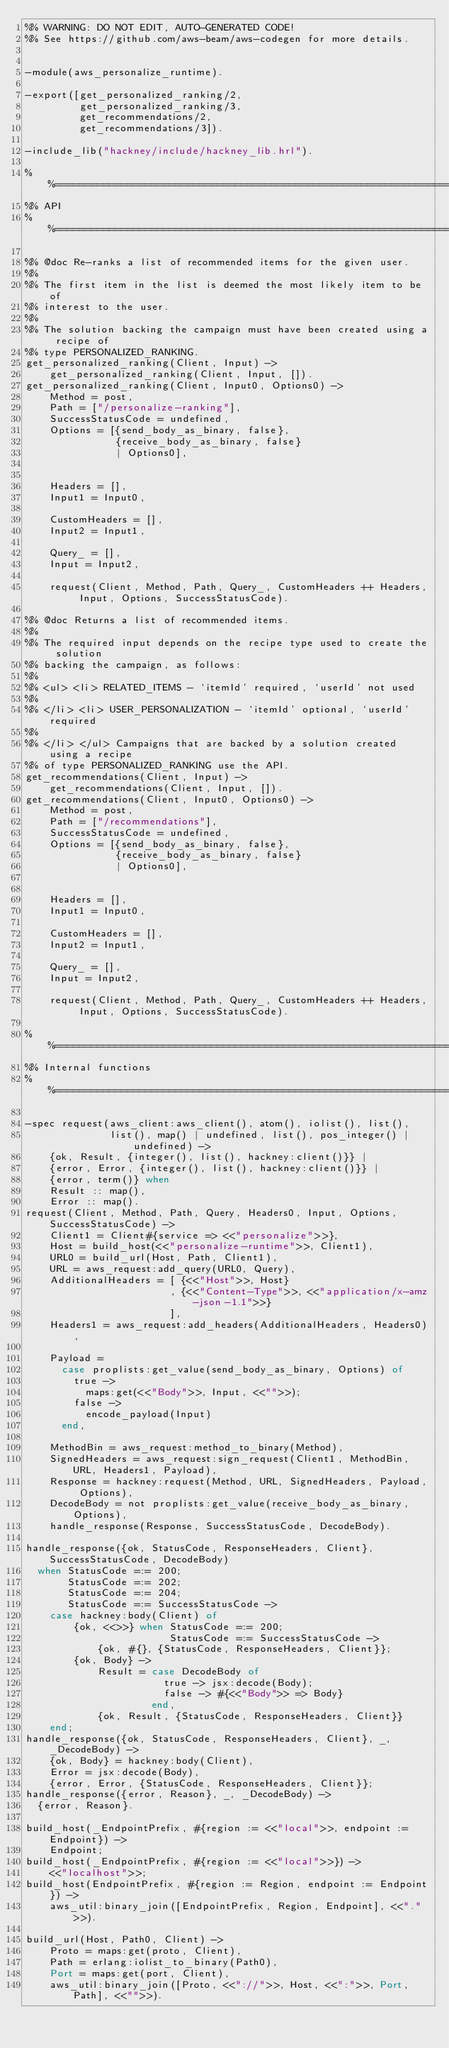<code> <loc_0><loc_0><loc_500><loc_500><_Erlang_>%% WARNING: DO NOT EDIT, AUTO-GENERATED CODE!
%% See https://github.com/aws-beam/aws-codegen for more details.


-module(aws_personalize_runtime).

-export([get_personalized_ranking/2,
         get_personalized_ranking/3,
         get_recommendations/2,
         get_recommendations/3]).

-include_lib("hackney/include/hackney_lib.hrl").

%%====================================================================
%% API
%%====================================================================

%% @doc Re-ranks a list of recommended items for the given user.
%%
%% The first item in the list is deemed the most likely item to be of
%% interest to the user.
%%
%% The solution backing the campaign must have been created using a recipe of
%% type PERSONALIZED_RANKING.
get_personalized_ranking(Client, Input) ->
    get_personalized_ranking(Client, Input, []).
get_personalized_ranking(Client, Input0, Options0) ->
    Method = post,
    Path = ["/personalize-ranking"],
    SuccessStatusCode = undefined,
    Options = [{send_body_as_binary, false},
               {receive_body_as_binary, false}
               | Options0],


    Headers = [],
    Input1 = Input0,

    CustomHeaders = [],
    Input2 = Input1,

    Query_ = [],
    Input = Input2,

    request(Client, Method, Path, Query_, CustomHeaders ++ Headers, Input, Options, SuccessStatusCode).

%% @doc Returns a list of recommended items.
%%
%% The required input depends on the recipe type used to create the solution
%% backing the campaign, as follows:
%%
%% <ul> <li> RELATED_ITEMS - `itemId' required, `userId' not used
%%
%% </li> <li> USER_PERSONALIZATION - `itemId' optional, `userId' required
%%
%% </li> </ul> Campaigns that are backed by a solution created using a recipe
%% of type PERSONALIZED_RANKING use the API.
get_recommendations(Client, Input) ->
    get_recommendations(Client, Input, []).
get_recommendations(Client, Input0, Options0) ->
    Method = post,
    Path = ["/recommendations"],
    SuccessStatusCode = undefined,
    Options = [{send_body_as_binary, false},
               {receive_body_as_binary, false}
               | Options0],


    Headers = [],
    Input1 = Input0,

    CustomHeaders = [],
    Input2 = Input1,

    Query_ = [],
    Input = Input2,

    request(Client, Method, Path, Query_, CustomHeaders ++ Headers, Input, Options, SuccessStatusCode).

%%====================================================================
%% Internal functions
%%====================================================================

-spec request(aws_client:aws_client(), atom(), iolist(), list(),
              list(), map() | undefined, list(), pos_integer() | undefined) ->
    {ok, Result, {integer(), list(), hackney:client()}} |
    {error, Error, {integer(), list(), hackney:client()}} |
    {error, term()} when
    Result :: map(),
    Error :: map().
request(Client, Method, Path, Query, Headers0, Input, Options, SuccessStatusCode) ->
    Client1 = Client#{service => <<"personalize">>},
    Host = build_host(<<"personalize-runtime">>, Client1),
    URL0 = build_url(Host, Path, Client1),
    URL = aws_request:add_query(URL0, Query),
    AdditionalHeaders = [ {<<"Host">>, Host}
                        , {<<"Content-Type">>, <<"application/x-amz-json-1.1">>}
                        ],
    Headers1 = aws_request:add_headers(AdditionalHeaders, Headers0),

    Payload =
      case proplists:get_value(send_body_as_binary, Options) of
        true ->
          maps:get(<<"Body">>, Input, <<"">>);
        false ->
          encode_payload(Input)
      end,

    MethodBin = aws_request:method_to_binary(Method),
    SignedHeaders = aws_request:sign_request(Client1, MethodBin, URL, Headers1, Payload),
    Response = hackney:request(Method, URL, SignedHeaders, Payload, Options),
    DecodeBody = not proplists:get_value(receive_body_as_binary, Options),
    handle_response(Response, SuccessStatusCode, DecodeBody).

handle_response({ok, StatusCode, ResponseHeaders, Client}, SuccessStatusCode, DecodeBody)
  when StatusCode =:= 200;
       StatusCode =:= 202;
       StatusCode =:= 204;
       StatusCode =:= SuccessStatusCode ->
    case hackney:body(Client) of
        {ok, <<>>} when StatusCode =:= 200;
                        StatusCode =:= SuccessStatusCode ->
            {ok, #{}, {StatusCode, ResponseHeaders, Client}};
        {ok, Body} ->
            Result = case DecodeBody of
                       true -> jsx:decode(Body);
                       false -> #{<<"Body">> => Body}
                     end,
            {ok, Result, {StatusCode, ResponseHeaders, Client}}
    end;
handle_response({ok, StatusCode, ResponseHeaders, Client}, _, _DecodeBody) ->
    {ok, Body} = hackney:body(Client),
    Error = jsx:decode(Body),
    {error, Error, {StatusCode, ResponseHeaders, Client}};
handle_response({error, Reason}, _, _DecodeBody) ->
  {error, Reason}.

build_host(_EndpointPrefix, #{region := <<"local">>, endpoint := Endpoint}) ->
    Endpoint;
build_host(_EndpointPrefix, #{region := <<"local">>}) ->
    <<"localhost">>;
build_host(EndpointPrefix, #{region := Region, endpoint := Endpoint}) ->
    aws_util:binary_join([EndpointPrefix, Region, Endpoint], <<".">>).

build_url(Host, Path0, Client) ->
    Proto = maps:get(proto, Client),
    Path = erlang:iolist_to_binary(Path0),
    Port = maps:get(port, Client),
    aws_util:binary_join([Proto, <<"://">>, Host, <<":">>, Port, Path], <<"">>).
</code> 